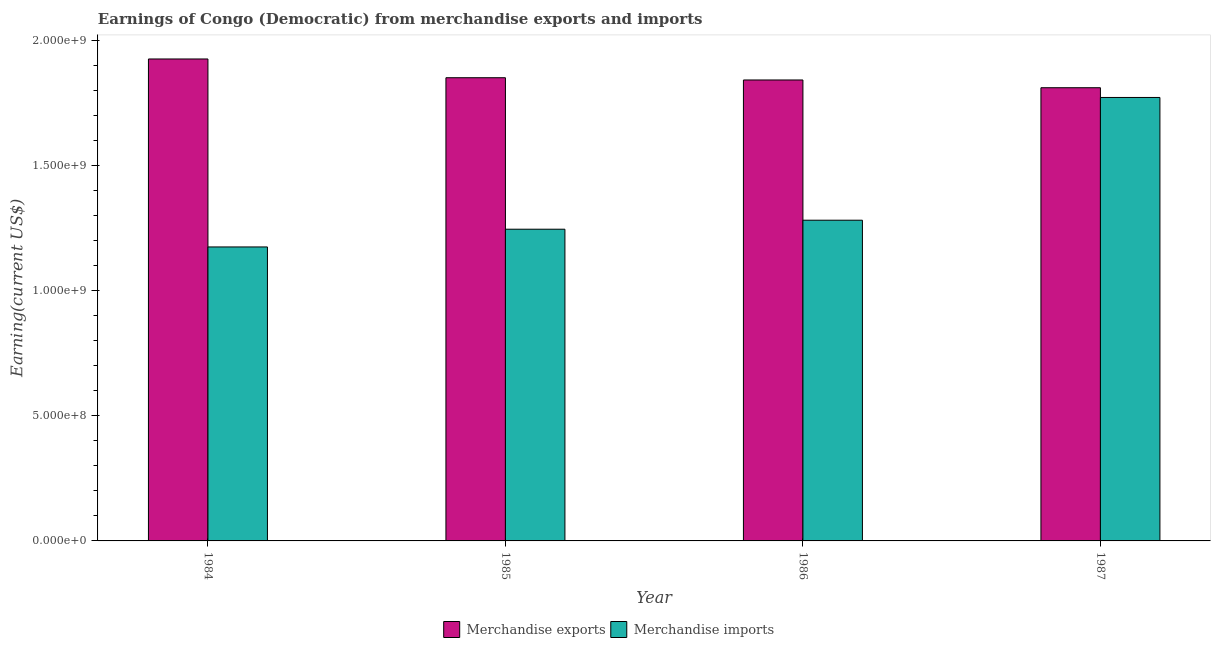Are the number of bars per tick equal to the number of legend labels?
Give a very brief answer. Yes. How many bars are there on the 2nd tick from the right?
Keep it short and to the point. 2. What is the label of the 2nd group of bars from the left?
Ensure brevity in your answer.  1985. In how many cases, is the number of bars for a given year not equal to the number of legend labels?
Give a very brief answer. 0. What is the earnings from merchandise exports in 1985?
Make the answer very short. 1.85e+09. Across all years, what is the maximum earnings from merchandise imports?
Ensure brevity in your answer.  1.77e+09. Across all years, what is the minimum earnings from merchandise imports?
Your response must be concise. 1.18e+09. In which year was the earnings from merchandise imports minimum?
Provide a short and direct response. 1984. What is the total earnings from merchandise imports in the graph?
Offer a terse response. 5.48e+09. What is the difference between the earnings from merchandise imports in 1984 and that in 1985?
Provide a succinct answer. -7.10e+07. What is the difference between the earnings from merchandise exports in 1985 and the earnings from merchandise imports in 1986?
Your answer should be compact. 9.00e+06. What is the average earnings from merchandise imports per year?
Your response must be concise. 1.37e+09. What is the ratio of the earnings from merchandise exports in 1986 to that in 1987?
Your answer should be compact. 1.02. Is the difference between the earnings from merchandise exports in 1985 and 1987 greater than the difference between the earnings from merchandise imports in 1985 and 1987?
Provide a short and direct response. No. What is the difference between the highest and the second highest earnings from merchandise exports?
Give a very brief answer. 7.50e+07. What is the difference between the highest and the lowest earnings from merchandise exports?
Ensure brevity in your answer.  1.15e+08. In how many years, is the earnings from merchandise imports greater than the average earnings from merchandise imports taken over all years?
Provide a succinct answer. 1. Is the sum of the earnings from merchandise exports in 1986 and 1987 greater than the maximum earnings from merchandise imports across all years?
Provide a short and direct response. Yes. How many years are there in the graph?
Your answer should be very brief. 4. Are the values on the major ticks of Y-axis written in scientific E-notation?
Your response must be concise. Yes. Where does the legend appear in the graph?
Offer a terse response. Bottom center. How are the legend labels stacked?
Your answer should be compact. Horizontal. What is the title of the graph?
Offer a terse response. Earnings of Congo (Democratic) from merchandise exports and imports. What is the label or title of the Y-axis?
Give a very brief answer. Earning(current US$). What is the Earning(current US$) in Merchandise exports in 1984?
Offer a very short reply. 1.93e+09. What is the Earning(current US$) of Merchandise imports in 1984?
Give a very brief answer. 1.18e+09. What is the Earning(current US$) of Merchandise exports in 1985?
Keep it short and to the point. 1.85e+09. What is the Earning(current US$) of Merchandise imports in 1985?
Keep it short and to the point. 1.25e+09. What is the Earning(current US$) of Merchandise exports in 1986?
Keep it short and to the point. 1.84e+09. What is the Earning(current US$) in Merchandise imports in 1986?
Your answer should be very brief. 1.28e+09. What is the Earning(current US$) in Merchandise exports in 1987?
Your answer should be very brief. 1.81e+09. What is the Earning(current US$) in Merchandise imports in 1987?
Keep it short and to the point. 1.77e+09. Across all years, what is the maximum Earning(current US$) of Merchandise exports?
Offer a terse response. 1.93e+09. Across all years, what is the maximum Earning(current US$) in Merchandise imports?
Your answer should be compact. 1.77e+09. Across all years, what is the minimum Earning(current US$) in Merchandise exports?
Offer a very short reply. 1.81e+09. Across all years, what is the minimum Earning(current US$) in Merchandise imports?
Offer a very short reply. 1.18e+09. What is the total Earning(current US$) in Merchandise exports in the graph?
Your answer should be very brief. 7.44e+09. What is the total Earning(current US$) of Merchandise imports in the graph?
Offer a terse response. 5.48e+09. What is the difference between the Earning(current US$) in Merchandise exports in 1984 and that in 1985?
Provide a short and direct response. 7.50e+07. What is the difference between the Earning(current US$) of Merchandise imports in 1984 and that in 1985?
Offer a terse response. -7.10e+07. What is the difference between the Earning(current US$) of Merchandise exports in 1984 and that in 1986?
Your answer should be very brief. 8.40e+07. What is the difference between the Earning(current US$) of Merchandise imports in 1984 and that in 1986?
Your response must be concise. -1.07e+08. What is the difference between the Earning(current US$) of Merchandise exports in 1984 and that in 1987?
Give a very brief answer. 1.15e+08. What is the difference between the Earning(current US$) in Merchandise imports in 1984 and that in 1987?
Offer a very short reply. -5.98e+08. What is the difference between the Earning(current US$) of Merchandise exports in 1985 and that in 1986?
Your response must be concise. 9.00e+06. What is the difference between the Earning(current US$) in Merchandise imports in 1985 and that in 1986?
Make the answer very short. -3.60e+07. What is the difference between the Earning(current US$) of Merchandise exports in 1985 and that in 1987?
Provide a short and direct response. 4.00e+07. What is the difference between the Earning(current US$) of Merchandise imports in 1985 and that in 1987?
Keep it short and to the point. -5.27e+08. What is the difference between the Earning(current US$) in Merchandise exports in 1986 and that in 1987?
Ensure brevity in your answer.  3.10e+07. What is the difference between the Earning(current US$) in Merchandise imports in 1986 and that in 1987?
Ensure brevity in your answer.  -4.91e+08. What is the difference between the Earning(current US$) in Merchandise exports in 1984 and the Earning(current US$) in Merchandise imports in 1985?
Your answer should be very brief. 6.81e+08. What is the difference between the Earning(current US$) of Merchandise exports in 1984 and the Earning(current US$) of Merchandise imports in 1986?
Give a very brief answer. 6.45e+08. What is the difference between the Earning(current US$) of Merchandise exports in 1984 and the Earning(current US$) of Merchandise imports in 1987?
Ensure brevity in your answer.  1.54e+08. What is the difference between the Earning(current US$) of Merchandise exports in 1985 and the Earning(current US$) of Merchandise imports in 1986?
Provide a succinct answer. 5.70e+08. What is the difference between the Earning(current US$) of Merchandise exports in 1985 and the Earning(current US$) of Merchandise imports in 1987?
Offer a terse response. 7.90e+07. What is the difference between the Earning(current US$) of Merchandise exports in 1986 and the Earning(current US$) of Merchandise imports in 1987?
Your response must be concise. 7.00e+07. What is the average Earning(current US$) in Merchandise exports per year?
Give a very brief answer. 1.86e+09. What is the average Earning(current US$) of Merchandise imports per year?
Your answer should be compact. 1.37e+09. In the year 1984, what is the difference between the Earning(current US$) in Merchandise exports and Earning(current US$) in Merchandise imports?
Make the answer very short. 7.52e+08. In the year 1985, what is the difference between the Earning(current US$) in Merchandise exports and Earning(current US$) in Merchandise imports?
Your answer should be very brief. 6.06e+08. In the year 1986, what is the difference between the Earning(current US$) in Merchandise exports and Earning(current US$) in Merchandise imports?
Your answer should be very brief. 5.61e+08. In the year 1987, what is the difference between the Earning(current US$) of Merchandise exports and Earning(current US$) of Merchandise imports?
Offer a terse response. 3.90e+07. What is the ratio of the Earning(current US$) of Merchandise exports in 1984 to that in 1985?
Offer a terse response. 1.04. What is the ratio of the Earning(current US$) of Merchandise imports in 1984 to that in 1985?
Ensure brevity in your answer.  0.94. What is the ratio of the Earning(current US$) in Merchandise exports in 1984 to that in 1986?
Provide a short and direct response. 1.05. What is the ratio of the Earning(current US$) in Merchandise imports in 1984 to that in 1986?
Keep it short and to the point. 0.92. What is the ratio of the Earning(current US$) of Merchandise exports in 1984 to that in 1987?
Your answer should be very brief. 1.06. What is the ratio of the Earning(current US$) in Merchandise imports in 1984 to that in 1987?
Ensure brevity in your answer.  0.66. What is the ratio of the Earning(current US$) of Merchandise exports in 1985 to that in 1986?
Keep it short and to the point. 1. What is the ratio of the Earning(current US$) in Merchandise imports in 1985 to that in 1986?
Make the answer very short. 0.97. What is the ratio of the Earning(current US$) of Merchandise exports in 1985 to that in 1987?
Give a very brief answer. 1.02. What is the ratio of the Earning(current US$) in Merchandise imports in 1985 to that in 1987?
Give a very brief answer. 0.7. What is the ratio of the Earning(current US$) in Merchandise exports in 1986 to that in 1987?
Keep it short and to the point. 1.02. What is the ratio of the Earning(current US$) in Merchandise imports in 1986 to that in 1987?
Your response must be concise. 0.72. What is the difference between the highest and the second highest Earning(current US$) of Merchandise exports?
Make the answer very short. 7.50e+07. What is the difference between the highest and the second highest Earning(current US$) of Merchandise imports?
Offer a very short reply. 4.91e+08. What is the difference between the highest and the lowest Earning(current US$) in Merchandise exports?
Provide a succinct answer. 1.15e+08. What is the difference between the highest and the lowest Earning(current US$) in Merchandise imports?
Give a very brief answer. 5.98e+08. 